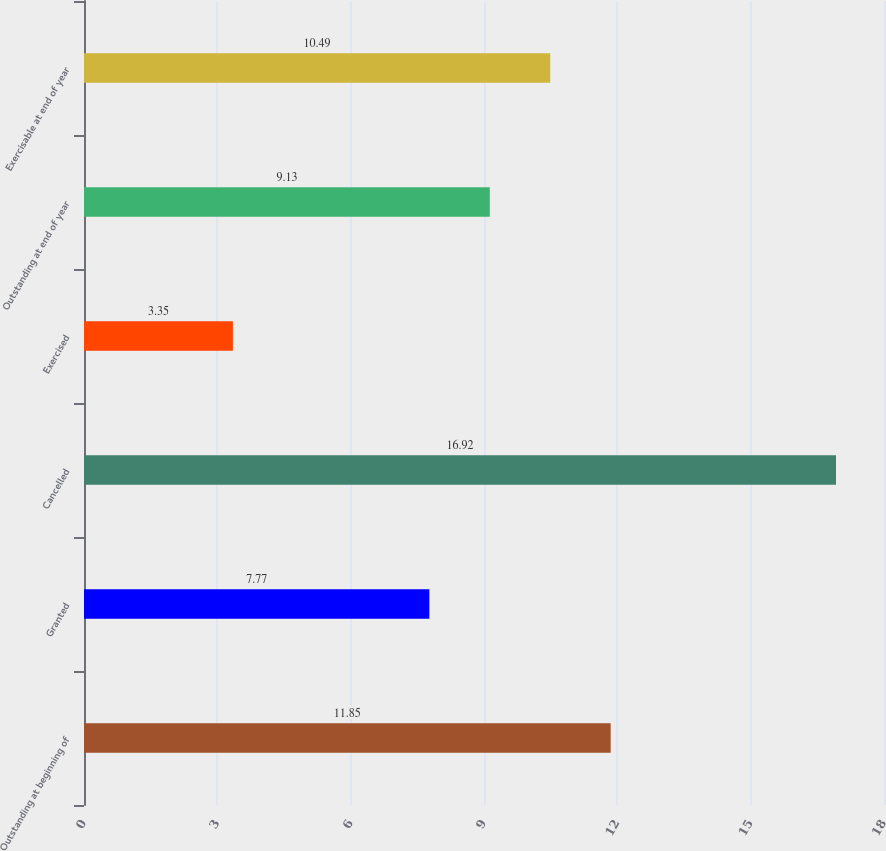<chart> <loc_0><loc_0><loc_500><loc_500><bar_chart><fcel>Outstanding at beginning of<fcel>Granted<fcel>Cancelled<fcel>Exercised<fcel>Outstanding at end of year<fcel>Exercisable at end of year<nl><fcel>11.85<fcel>7.77<fcel>16.92<fcel>3.35<fcel>9.13<fcel>10.49<nl></chart> 